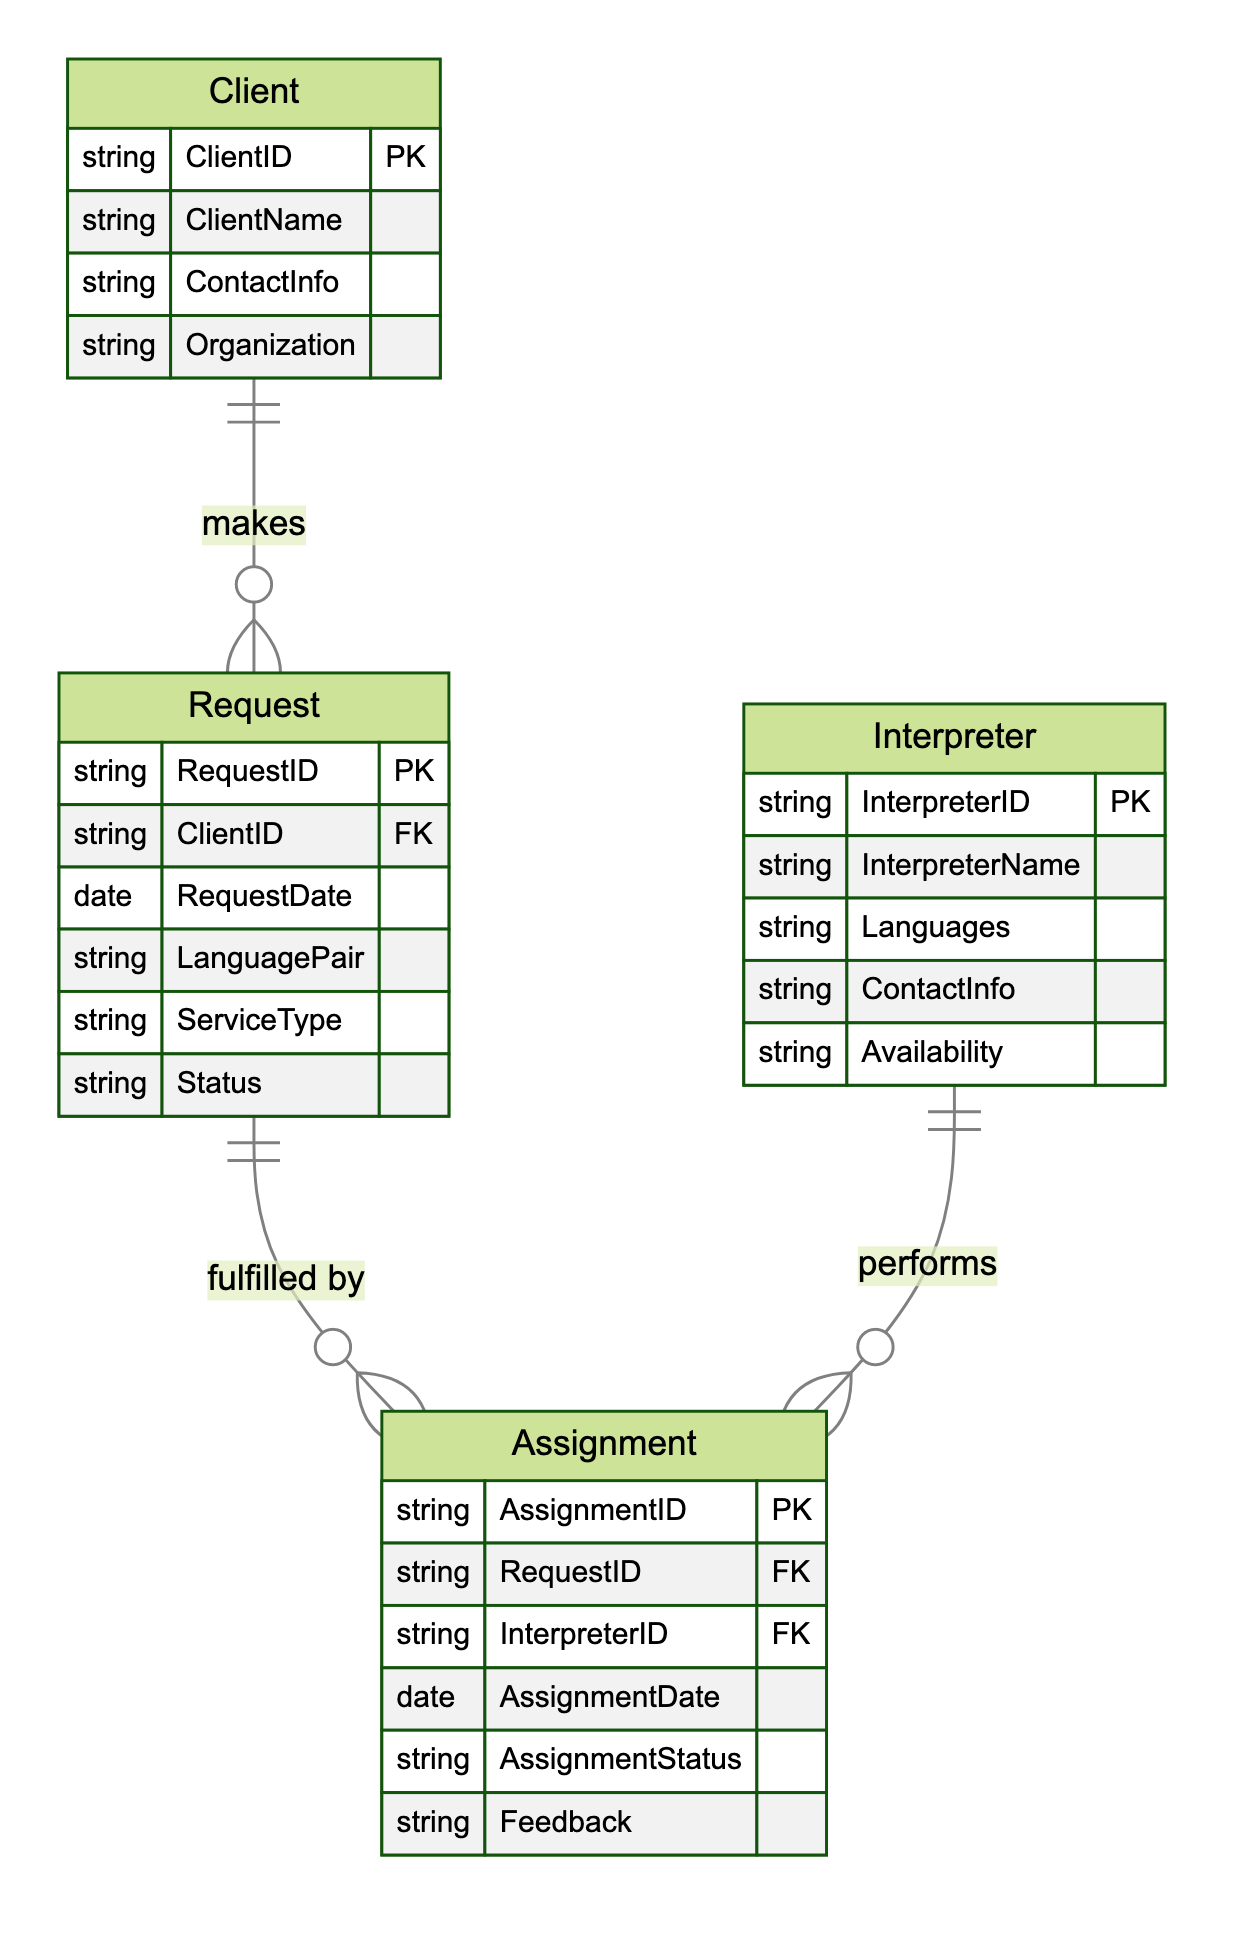What is the primary key of the Client entity? The primary key of the Client entity is ClientID, which is indicated as "Primary Key" in the attributes section of the Client entity.
Answer: ClientID How many attributes does the Assignment entity have? The Assignment entity has six attributes listed: AssignmentID, RequestID, InterpreterID, AssignmentDate, AssignmentStatus, and Feedback. Counting these provides the total.
Answer: 6 What relationship exists between Request and Assignment? The relationship between Request and Assignment is "fulfilled by," as clearly indicated by the arrow connecting them in the diagram, showing a one-to-many relationship.
Answer: fulfilled by Which entity has the attribute "Availability"? The attribute "Availability" is associated with the Interpreter entity, as specified in its attributes section.
Answer: Interpreter How many entities are represented in the diagram? The diagram contains four entities: Client, Request, Interpreter, and Assignment. Counting them provides the total entity count.
Answer: 4 What is the status of a Request if it is assigned to an Interpreter? The status of a Request can vary, but it is effectively tied to the completion of the related Assignment, which indicates fulfillment. To determine the specific status, we would need to refer to the actual data for each request.
Answer: Varies In which entities is the attribute "RequestID" found? The attribute "RequestID" is found in the Request entity as a primary key and in the Assignment entity as a foreign key, indicating its role in connecting these entities.
Answer: Request and Assignment What does the relationship type "OneToMany" signify between Client and Request? The "OneToMany" relationship signifies that a single Client can make multiple Requests, indicating a hierarchical connection where one entity is linked to multiple instances of another.
Answer: OneToMany How many different ServiceTypes can be associated with a Request? The number of different ServiceTypes can be multiple; however, the diagram itself does not specify how many types exist, thus we can't define a specific count based solely on the diagram without additional data.
Answer: Varies 